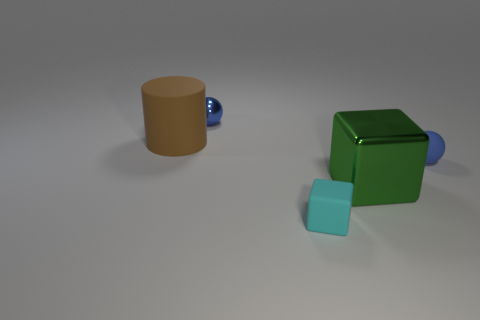Add 2 tiny red metal cylinders. How many objects exist? 7 Subtract all brown balls. How many cyan cubes are left? 1 Subtract all small blue cubes. Subtract all blue metallic objects. How many objects are left? 4 Add 2 tiny blue matte objects. How many tiny blue matte objects are left? 3 Add 5 tiny matte objects. How many tiny matte objects exist? 7 Subtract 1 brown cylinders. How many objects are left? 4 Subtract all cylinders. How many objects are left? 4 Subtract 1 blocks. How many blocks are left? 1 Subtract all yellow spheres. Subtract all brown cylinders. How many spheres are left? 2 